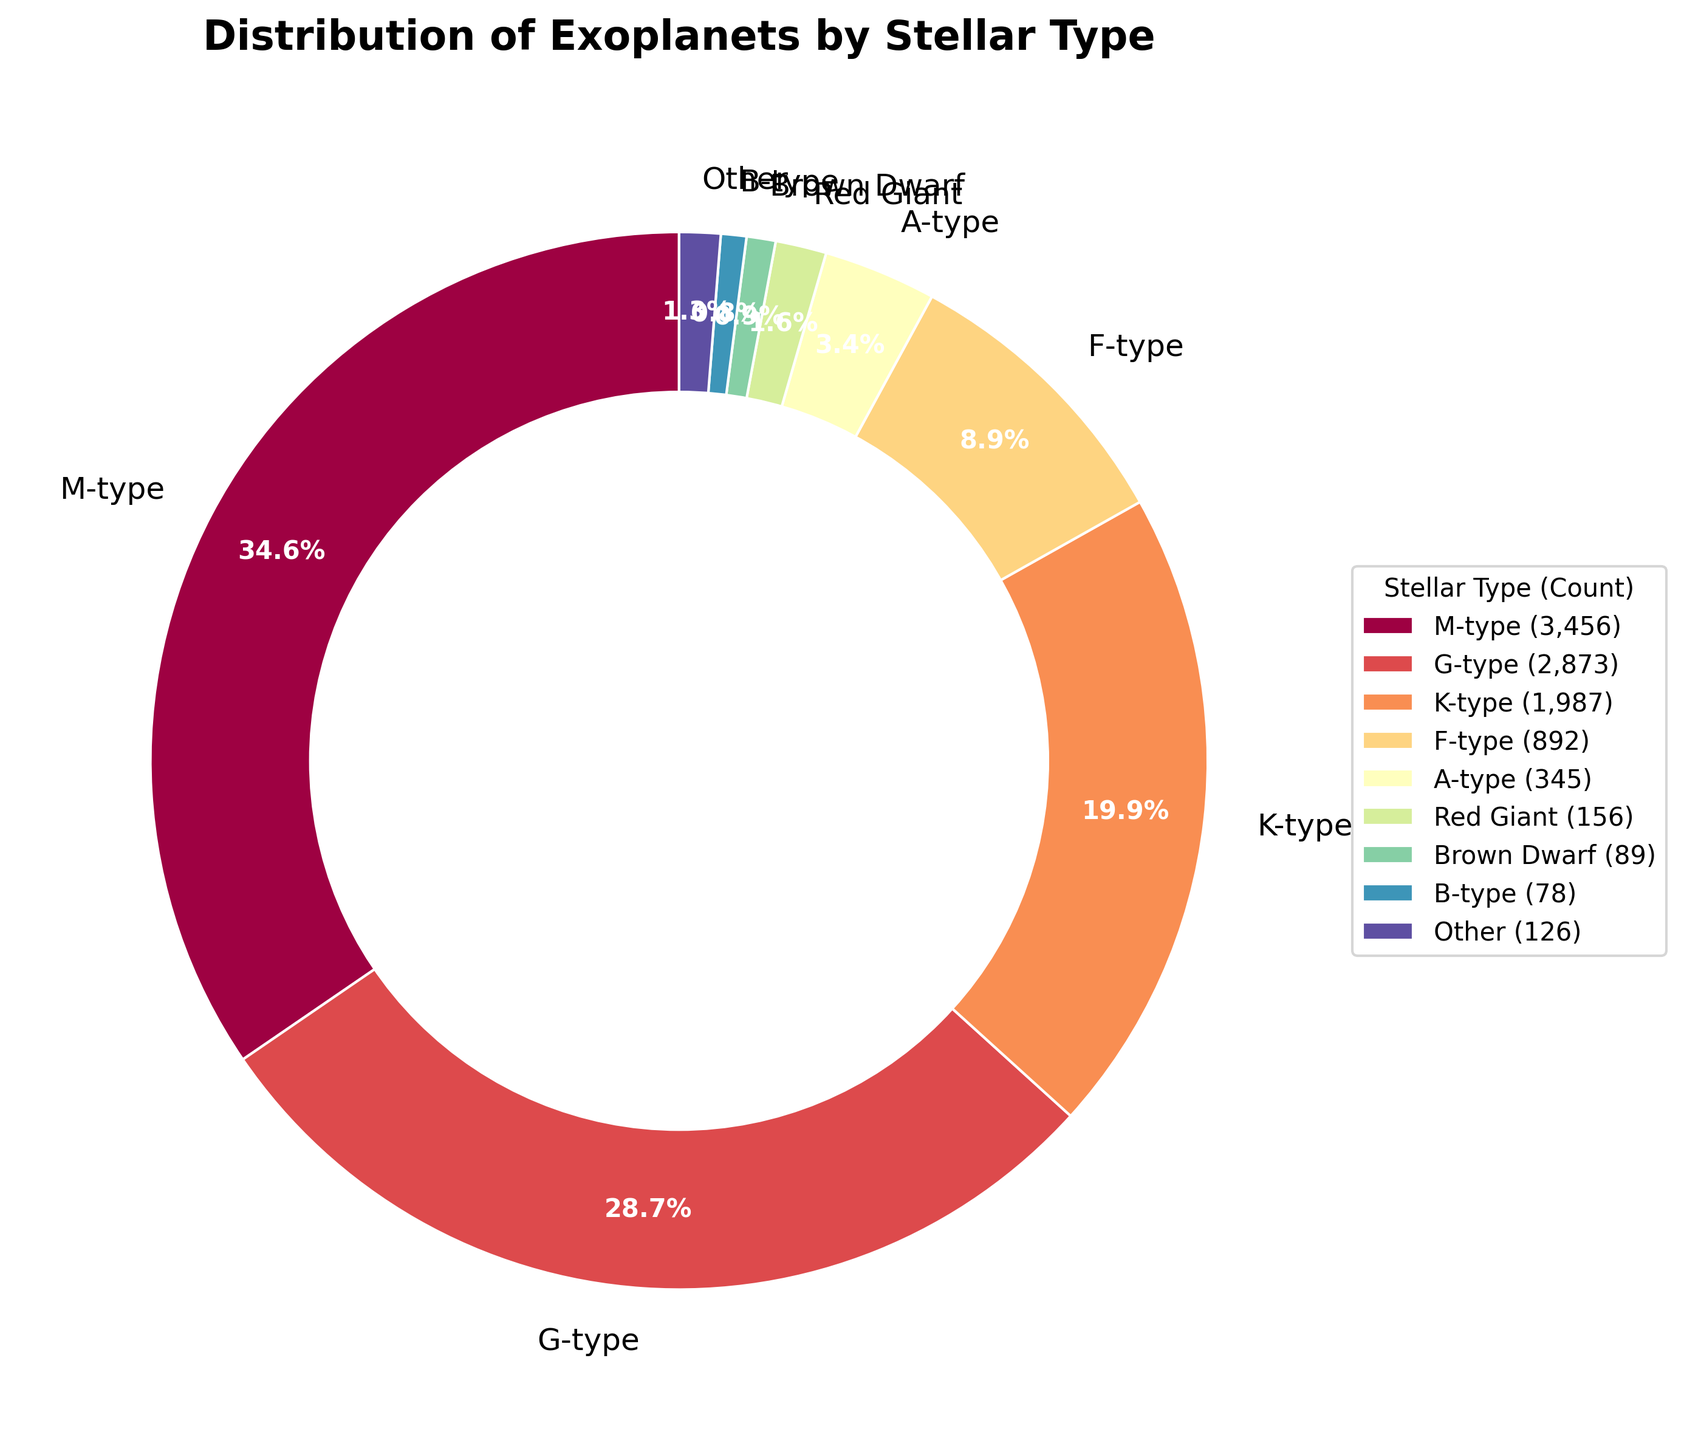Which stellar type hosts the highest number of exoplanets? By examining the slices of the pie chart, the largest slice corresponds to the M-type stars.
Answer: M-type Which stellar type hosts fewer exoplanets, F-type or A-type? By comparing the slices for F-type and A-type, F-type hosts 892 exoplanets while A-type hosts 345 exoplanets. Therefore, A-type hosts fewer exoplanets.
Answer: A-type What percentage of exoplanets are hosted by G-type stars? From the pie chart, the G-type stars account for 24.6% of the exoplanets. This can be read directly from the chart.
Answer: 24.6% How many stellar types are grouped into the 'Other' category? By examining the legend and the pie chart, we notice that the 'Other' category includes all stellar types beyond the top 8, which are L-type, T-type, White Dwarf, Red Giant, Brown Dwarf, Subdwarf, and Neutron Star. That's a total of 7 stellar types.
Answer: 7 What's the total number of exoplanets hosted by B-type, O-type, and T-type stars combined? Taking the numbers from the pie chart: B-type (78) + O-type (12) + T-type (6) equals 96.
Answer: 96 Which is greater: the number of exoplanets hosted by K-type stars or the sum of exoplanets hosted by F-type, A-type, and B-type stars? F-type (892) + A-type (345) + B-type (78) = 1315. K-type hosts 1987. Since 1987 > 1315, K-type hosts a greater number.
Answer: K-type What proportion of exoplanets are hosted by stellar types grouped under 'Other'? The pie chart shows the 'Other' category representing 1.2% of the total exoplanets. This can be read directly from the chart.
Answer: 1.2% What is the total number of exoplanets hosted by M-type and G-type stars? By adding the numbers from the pie chart: M-type (3456) + G-type (2873) = 6329 exoplanets.
Answer: 6329 Which slice of the pie chart has the smallest percentage and what is that percentage? The smallest slice corresponds to Neutron Star types, which host 0.0% of the exoplanets.
Answer: 0.0% How do the number of exoplanets hosted by red giants compare to those hosted by brown dwarfs? By examining the pie chart slices, Red Giants host 156 exoplanets while Brown Dwarfs host 89. Therefore, Red Giants host more exoplanets.
Answer: Red Giants 